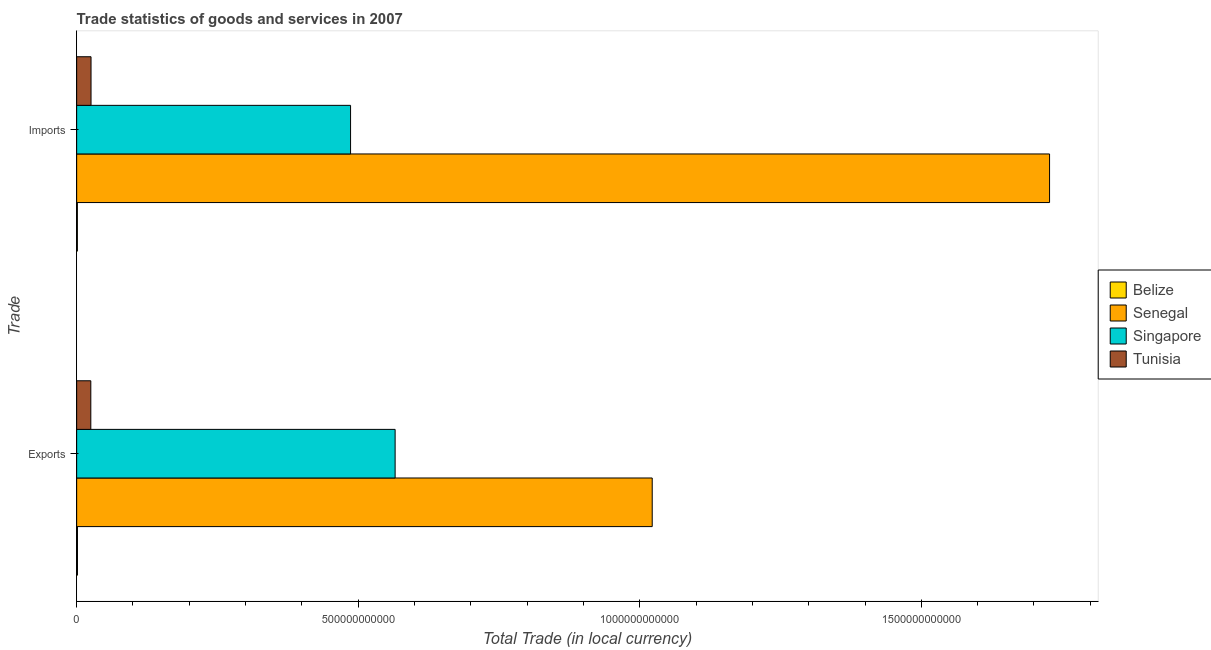How many groups of bars are there?
Provide a succinct answer. 2. Are the number of bars on each tick of the Y-axis equal?
Your response must be concise. Yes. How many bars are there on the 1st tick from the top?
Give a very brief answer. 4. What is the label of the 2nd group of bars from the top?
Provide a succinct answer. Exports. What is the export of goods and services in Senegal?
Offer a terse response. 1.02e+12. Across all countries, what is the maximum imports of goods and services?
Keep it short and to the point. 1.73e+12. Across all countries, what is the minimum export of goods and services?
Offer a very short reply. 1.43e+09. In which country was the imports of goods and services maximum?
Your answer should be very brief. Senegal. In which country was the export of goods and services minimum?
Your answer should be very brief. Belize. What is the total export of goods and services in the graph?
Offer a terse response. 1.61e+12. What is the difference between the imports of goods and services in Belize and that in Singapore?
Your response must be concise. -4.85e+11. What is the difference between the imports of goods and services in Singapore and the export of goods and services in Belize?
Provide a succinct answer. 4.85e+11. What is the average imports of goods and services per country?
Keep it short and to the point. 5.60e+11. What is the difference between the export of goods and services and imports of goods and services in Belize?
Your response must be concise. 1.59e+08. In how many countries, is the export of goods and services greater than 200000000000 LCU?
Your answer should be compact. 2. What is the ratio of the imports of goods and services in Singapore to that in Belize?
Your response must be concise. 383.54. In how many countries, is the export of goods and services greater than the average export of goods and services taken over all countries?
Your answer should be very brief. 2. What does the 4th bar from the top in Imports represents?
Provide a short and direct response. Belize. What does the 4th bar from the bottom in Imports represents?
Give a very brief answer. Tunisia. What is the difference between two consecutive major ticks on the X-axis?
Offer a very short reply. 5.00e+11. Does the graph contain grids?
Offer a terse response. No. What is the title of the graph?
Make the answer very short. Trade statistics of goods and services in 2007. Does "Europe(developing only)" appear as one of the legend labels in the graph?
Offer a very short reply. No. What is the label or title of the X-axis?
Your answer should be compact. Total Trade (in local currency). What is the label or title of the Y-axis?
Your answer should be compact. Trade. What is the Total Trade (in local currency) of Belize in Exports?
Your answer should be compact. 1.43e+09. What is the Total Trade (in local currency) of Senegal in Exports?
Your answer should be compact. 1.02e+12. What is the Total Trade (in local currency) of Singapore in Exports?
Offer a terse response. 5.66e+11. What is the Total Trade (in local currency) in Tunisia in Exports?
Give a very brief answer. 2.51e+1. What is the Total Trade (in local currency) in Belize in Imports?
Ensure brevity in your answer.  1.27e+09. What is the Total Trade (in local currency) in Senegal in Imports?
Your response must be concise. 1.73e+12. What is the Total Trade (in local currency) in Singapore in Imports?
Keep it short and to the point. 4.86e+11. What is the Total Trade (in local currency) of Tunisia in Imports?
Your answer should be compact. 2.55e+1. Across all Trade, what is the maximum Total Trade (in local currency) in Belize?
Provide a succinct answer. 1.43e+09. Across all Trade, what is the maximum Total Trade (in local currency) of Senegal?
Your response must be concise. 1.73e+12. Across all Trade, what is the maximum Total Trade (in local currency) in Singapore?
Your response must be concise. 5.66e+11. Across all Trade, what is the maximum Total Trade (in local currency) of Tunisia?
Provide a succinct answer. 2.55e+1. Across all Trade, what is the minimum Total Trade (in local currency) in Belize?
Your response must be concise. 1.27e+09. Across all Trade, what is the minimum Total Trade (in local currency) in Senegal?
Your answer should be very brief. 1.02e+12. Across all Trade, what is the minimum Total Trade (in local currency) in Singapore?
Provide a short and direct response. 4.86e+11. Across all Trade, what is the minimum Total Trade (in local currency) in Tunisia?
Your response must be concise. 2.51e+1. What is the total Total Trade (in local currency) of Belize in the graph?
Offer a terse response. 2.70e+09. What is the total Total Trade (in local currency) of Senegal in the graph?
Offer a very short reply. 2.75e+12. What is the total Total Trade (in local currency) of Singapore in the graph?
Give a very brief answer. 1.05e+12. What is the total Total Trade (in local currency) in Tunisia in the graph?
Make the answer very short. 5.07e+1. What is the difference between the Total Trade (in local currency) in Belize in Exports and that in Imports?
Provide a succinct answer. 1.59e+08. What is the difference between the Total Trade (in local currency) of Senegal in Exports and that in Imports?
Provide a short and direct response. -7.06e+11. What is the difference between the Total Trade (in local currency) of Singapore in Exports and that in Imports?
Give a very brief answer. 7.91e+1. What is the difference between the Total Trade (in local currency) in Tunisia in Exports and that in Imports?
Keep it short and to the point. -3.78e+08. What is the difference between the Total Trade (in local currency) in Belize in Exports and the Total Trade (in local currency) in Senegal in Imports?
Your answer should be compact. -1.73e+12. What is the difference between the Total Trade (in local currency) of Belize in Exports and the Total Trade (in local currency) of Singapore in Imports?
Offer a very short reply. -4.85e+11. What is the difference between the Total Trade (in local currency) of Belize in Exports and the Total Trade (in local currency) of Tunisia in Imports?
Offer a very short reply. -2.41e+1. What is the difference between the Total Trade (in local currency) in Senegal in Exports and the Total Trade (in local currency) in Singapore in Imports?
Ensure brevity in your answer.  5.36e+11. What is the difference between the Total Trade (in local currency) of Senegal in Exports and the Total Trade (in local currency) of Tunisia in Imports?
Offer a terse response. 9.97e+11. What is the difference between the Total Trade (in local currency) in Singapore in Exports and the Total Trade (in local currency) in Tunisia in Imports?
Provide a short and direct response. 5.40e+11. What is the average Total Trade (in local currency) in Belize per Trade?
Provide a succinct answer. 1.35e+09. What is the average Total Trade (in local currency) of Senegal per Trade?
Make the answer very short. 1.37e+12. What is the average Total Trade (in local currency) of Singapore per Trade?
Your answer should be compact. 5.26e+11. What is the average Total Trade (in local currency) in Tunisia per Trade?
Ensure brevity in your answer.  2.53e+1. What is the difference between the Total Trade (in local currency) in Belize and Total Trade (in local currency) in Senegal in Exports?
Keep it short and to the point. -1.02e+12. What is the difference between the Total Trade (in local currency) in Belize and Total Trade (in local currency) in Singapore in Exports?
Your answer should be very brief. -5.64e+11. What is the difference between the Total Trade (in local currency) in Belize and Total Trade (in local currency) in Tunisia in Exports?
Your response must be concise. -2.37e+1. What is the difference between the Total Trade (in local currency) in Senegal and Total Trade (in local currency) in Singapore in Exports?
Provide a short and direct response. 4.57e+11. What is the difference between the Total Trade (in local currency) of Senegal and Total Trade (in local currency) of Tunisia in Exports?
Provide a short and direct response. 9.97e+11. What is the difference between the Total Trade (in local currency) in Singapore and Total Trade (in local currency) in Tunisia in Exports?
Your answer should be very brief. 5.40e+11. What is the difference between the Total Trade (in local currency) of Belize and Total Trade (in local currency) of Senegal in Imports?
Provide a short and direct response. -1.73e+12. What is the difference between the Total Trade (in local currency) in Belize and Total Trade (in local currency) in Singapore in Imports?
Provide a short and direct response. -4.85e+11. What is the difference between the Total Trade (in local currency) of Belize and Total Trade (in local currency) of Tunisia in Imports?
Your answer should be very brief. -2.43e+1. What is the difference between the Total Trade (in local currency) of Senegal and Total Trade (in local currency) of Singapore in Imports?
Give a very brief answer. 1.24e+12. What is the difference between the Total Trade (in local currency) of Senegal and Total Trade (in local currency) of Tunisia in Imports?
Ensure brevity in your answer.  1.70e+12. What is the difference between the Total Trade (in local currency) in Singapore and Total Trade (in local currency) in Tunisia in Imports?
Make the answer very short. 4.61e+11. What is the ratio of the Total Trade (in local currency) in Belize in Exports to that in Imports?
Give a very brief answer. 1.13. What is the ratio of the Total Trade (in local currency) of Senegal in Exports to that in Imports?
Ensure brevity in your answer.  0.59. What is the ratio of the Total Trade (in local currency) of Singapore in Exports to that in Imports?
Your answer should be very brief. 1.16. What is the ratio of the Total Trade (in local currency) of Tunisia in Exports to that in Imports?
Give a very brief answer. 0.99. What is the difference between the highest and the second highest Total Trade (in local currency) of Belize?
Offer a very short reply. 1.59e+08. What is the difference between the highest and the second highest Total Trade (in local currency) of Senegal?
Give a very brief answer. 7.06e+11. What is the difference between the highest and the second highest Total Trade (in local currency) of Singapore?
Your response must be concise. 7.91e+1. What is the difference between the highest and the second highest Total Trade (in local currency) in Tunisia?
Provide a short and direct response. 3.78e+08. What is the difference between the highest and the lowest Total Trade (in local currency) of Belize?
Offer a very short reply. 1.59e+08. What is the difference between the highest and the lowest Total Trade (in local currency) in Senegal?
Offer a terse response. 7.06e+11. What is the difference between the highest and the lowest Total Trade (in local currency) in Singapore?
Provide a short and direct response. 7.91e+1. What is the difference between the highest and the lowest Total Trade (in local currency) of Tunisia?
Your answer should be very brief. 3.78e+08. 